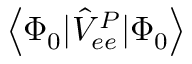Convert formula to latex. <formula><loc_0><loc_0><loc_500><loc_500>\left < \Phi _ { 0 } | \hat { V } _ { e e } ^ { P } | \Phi _ { 0 } \right ></formula> 